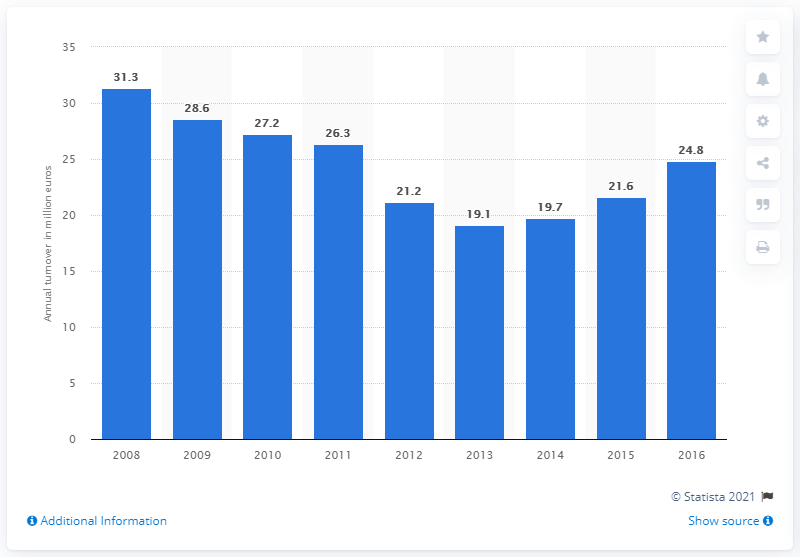Identify some key points in this picture. The turnover of the textile manufacturing industry in Cyprus in 2008 was 31.3 billion. 